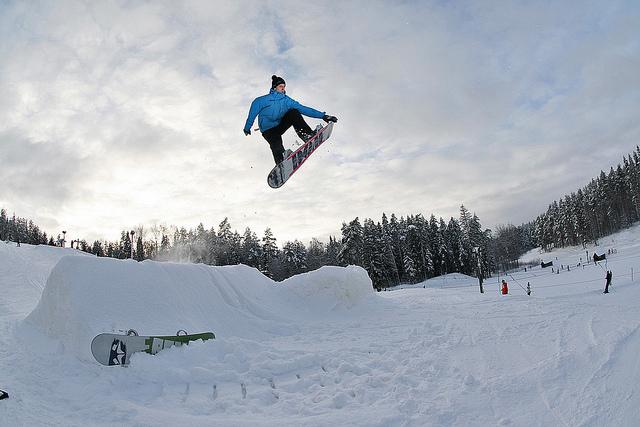What has someone lost in this picture?
Give a very brief answer. Snowboard. Is this picture taken at night?
Give a very brief answer. No. How far off the ground is the snowboarder?
Keep it brief. 10 feet. 